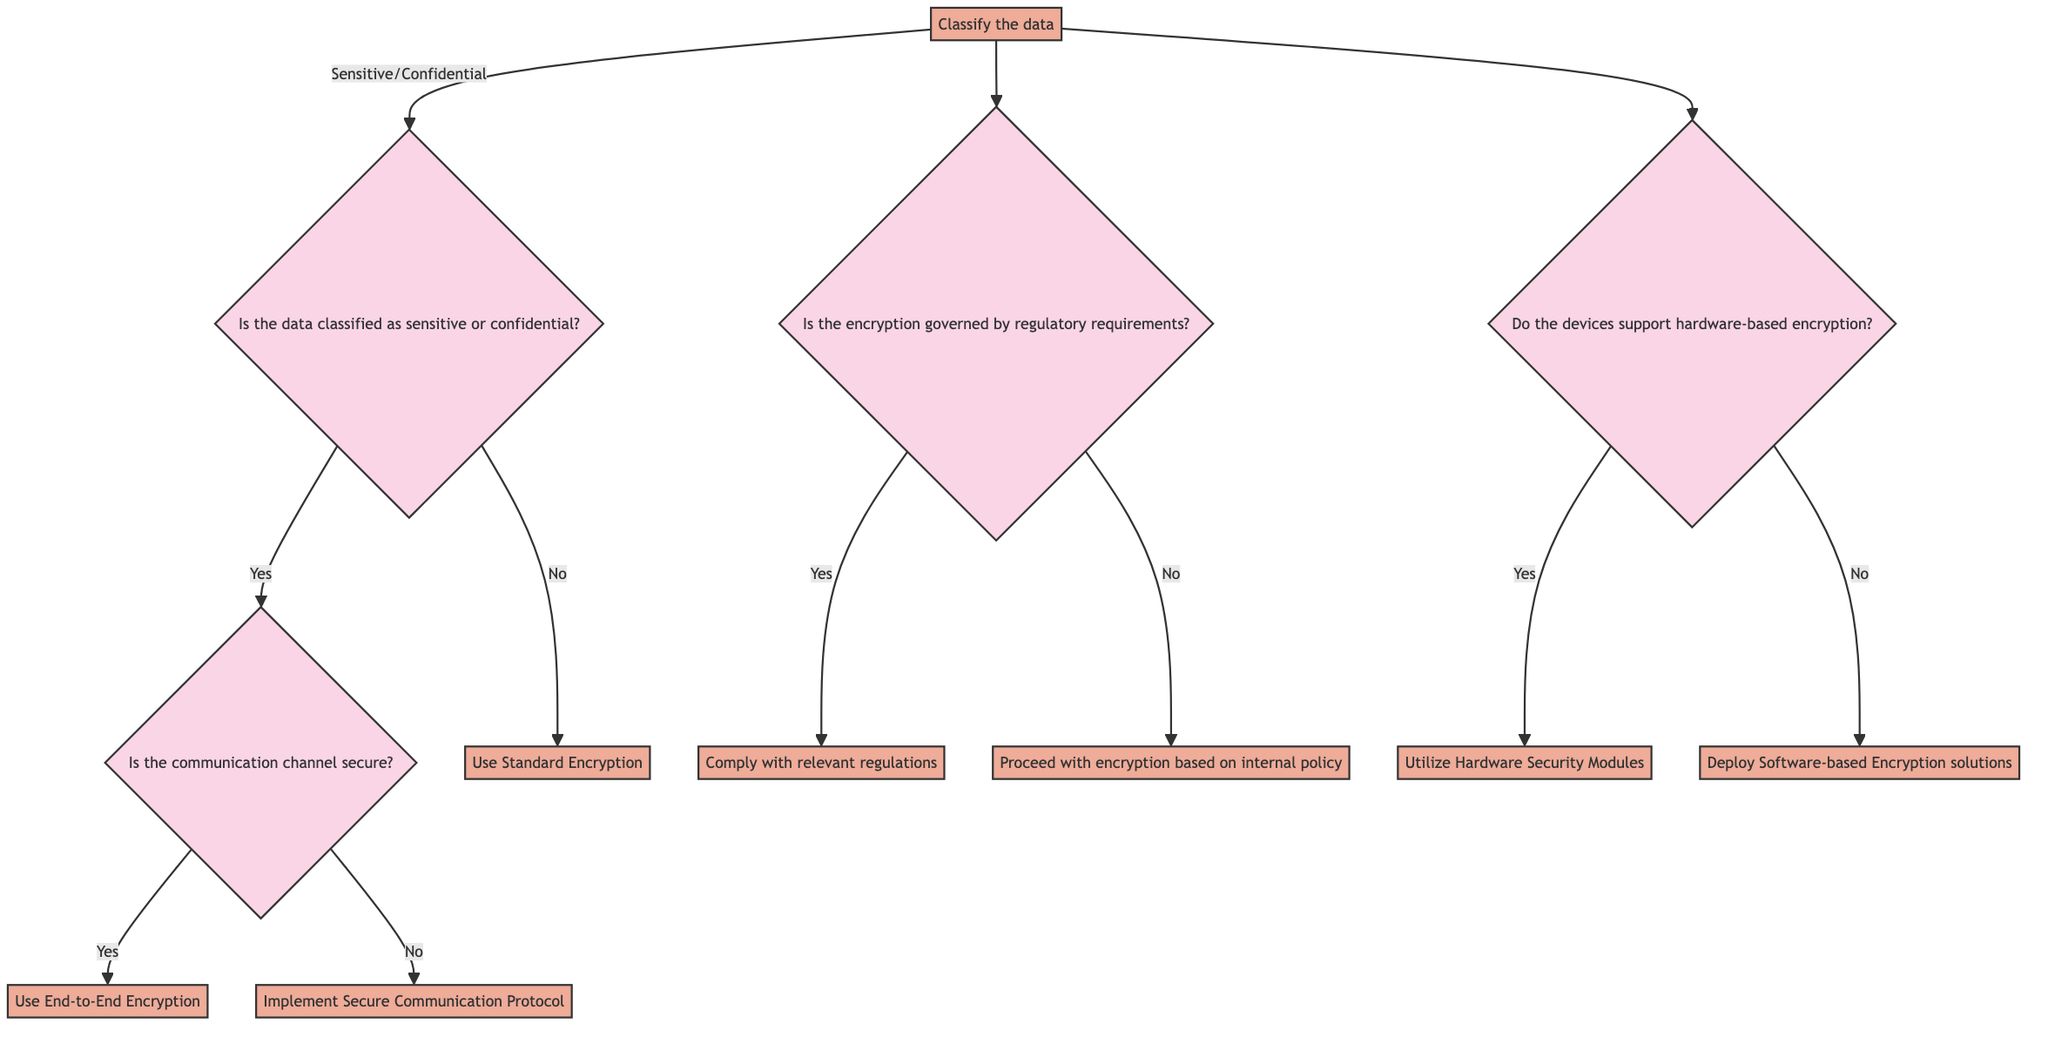Is the first decision node about data classification? The first decision node asks whether the data is classified as sensitive or confidential, thus confirming it is about data classification.
Answer: Yes How many actions are listed in the diagram? The diagram lists four actions: Classify the data, Evaluate the security of the communication channels, Check for regulatory compliance requirements, and Assess device capabilities for encryption, totaling four actions.
Answer: Four What is the first action in the flowchart? The first action in the flowchart is to classify the data based on sensitivity levels, identifying whether the data is public, internal, sensitive, or confidential.
Answer: Classify the data What happens if the communication channel is not secure? If the communication channel is not secure, the protocol outlined by the diagram directs to implement a secure communication protocol, such as IPSec.
Answer: Implement Secure Communication Protocol If the data is classified as sensitive, which question follows? If the data is classified as sensitive, the next question to evaluate would be whether the communication channel is secure.
Answer: Is the communication channel secure? What encryption should be used if no regulatory requirements apply? If there are no regulatory requirements governing the encryption, the decision is to proceed with encryption based on internal policy outlined in the decision tree.
Answer: Proceed with encryption based on internal policy How many decision nodes are in the diagram? The diagram contains four decision nodes: one about data classification, one about the security of the communication channel, one regarding regulatory requirements, and one on device support for hardware-based encryption, resulting in four decision nodes.
Answer: Four What encryption type is suggested if devices support hardware-based encryption? If devices support hardware-based encryption, the suggested encryption type is to utilize hardware security modules (HSMs).
Answer: Utilize Hardware Security Modules 